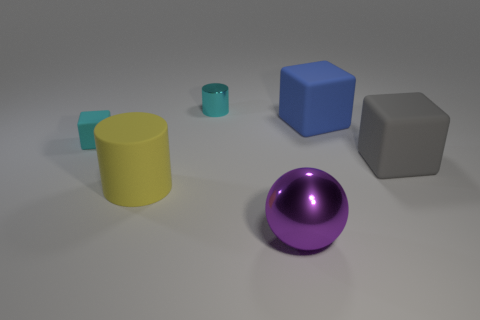Are there any tiny blocks that have the same color as the tiny cylinder?
Provide a succinct answer. Yes. There is a rubber thing that is the same color as the tiny metallic cylinder; what is its size?
Your answer should be compact. Small. Is the small shiny cylinder the same color as the tiny matte thing?
Provide a short and direct response. Yes. There is a metallic thing to the left of the large metallic thing; is it the same color as the small matte thing?
Your answer should be very brief. Yes. There is another thing that is the same color as the small shiny thing; what is it made of?
Give a very brief answer. Rubber. Are there any cylinders of the same size as the gray matte thing?
Provide a succinct answer. Yes. Are there fewer shiny spheres that are behind the purple thing than blocks?
Offer a very short reply. Yes. Are there fewer cyan objects that are in front of the large shiny sphere than objects that are right of the yellow rubber thing?
Your answer should be very brief. Yes. How many cubes are cyan matte objects or shiny objects?
Provide a succinct answer. 1. Is the material of the cube to the left of the large metal ball the same as the small cylinder behind the purple object?
Keep it short and to the point. No. 